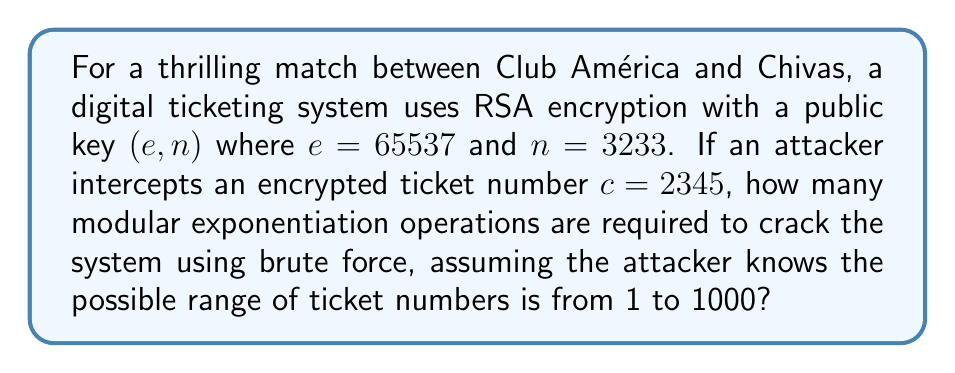Could you help me with this problem? To solve this problem, we need to understand the RSA encryption process and how brute force attacks work:

1) In RSA, encryption is done using the formula:
   $c \equiv m^e \pmod{n}$
   where $m$ is the original message (ticket number in this case).

2) To decrypt, we need to find $m$ such that $m^e \equiv c \pmod{n}$.

3) In a brute force attack, we try all possible values of $m$ until we find the correct one.

4) Given the range of ticket numbers (1 to 1000), we need to perform the following operation for each possible $m$:
   $m^e \bmod n$

5) We then compare each result with the intercepted ciphertext $c = 2345$.

6) The number of modular exponentiation operations required is equal to the number of possible ticket numbers, which is 1000.

This brute force approach is feasible due to the small key size and limited range of possible ticket numbers, highlighting the importance of using sufficiently large key sizes and message spaces in real-world cryptographic systems.
Answer: 1000 